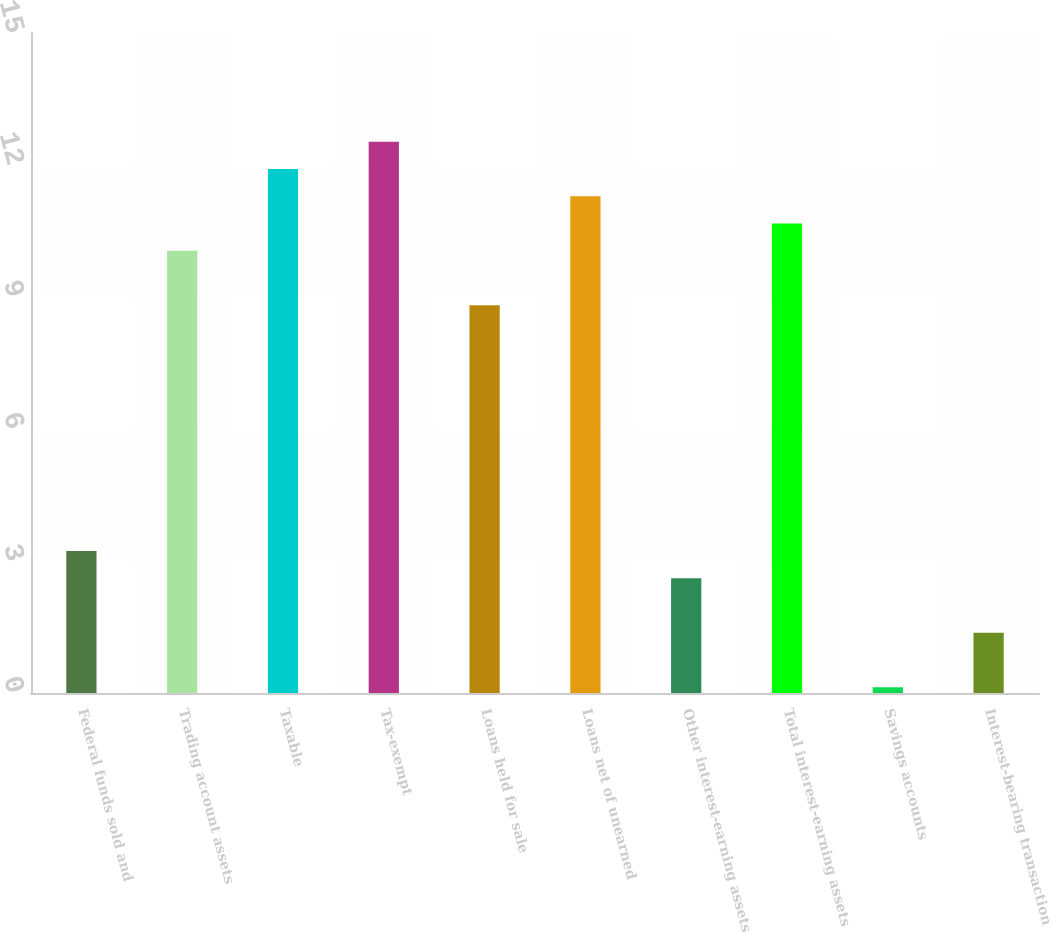Convert chart to OTSL. <chart><loc_0><loc_0><loc_500><loc_500><bar_chart><fcel>Federal funds sold and<fcel>Trading account assets<fcel>Taxable<fcel>Tax-exempt<fcel>Loans held for sale<fcel>Loans net of unearned<fcel>Other interest-earning assets<fcel>Total interest-earning assets<fcel>Savings accounts<fcel>Interest-bearing transaction<nl><fcel>3.23<fcel>10.05<fcel>11.91<fcel>12.53<fcel>8.81<fcel>11.29<fcel>2.61<fcel>10.67<fcel>0.13<fcel>1.37<nl></chart> 